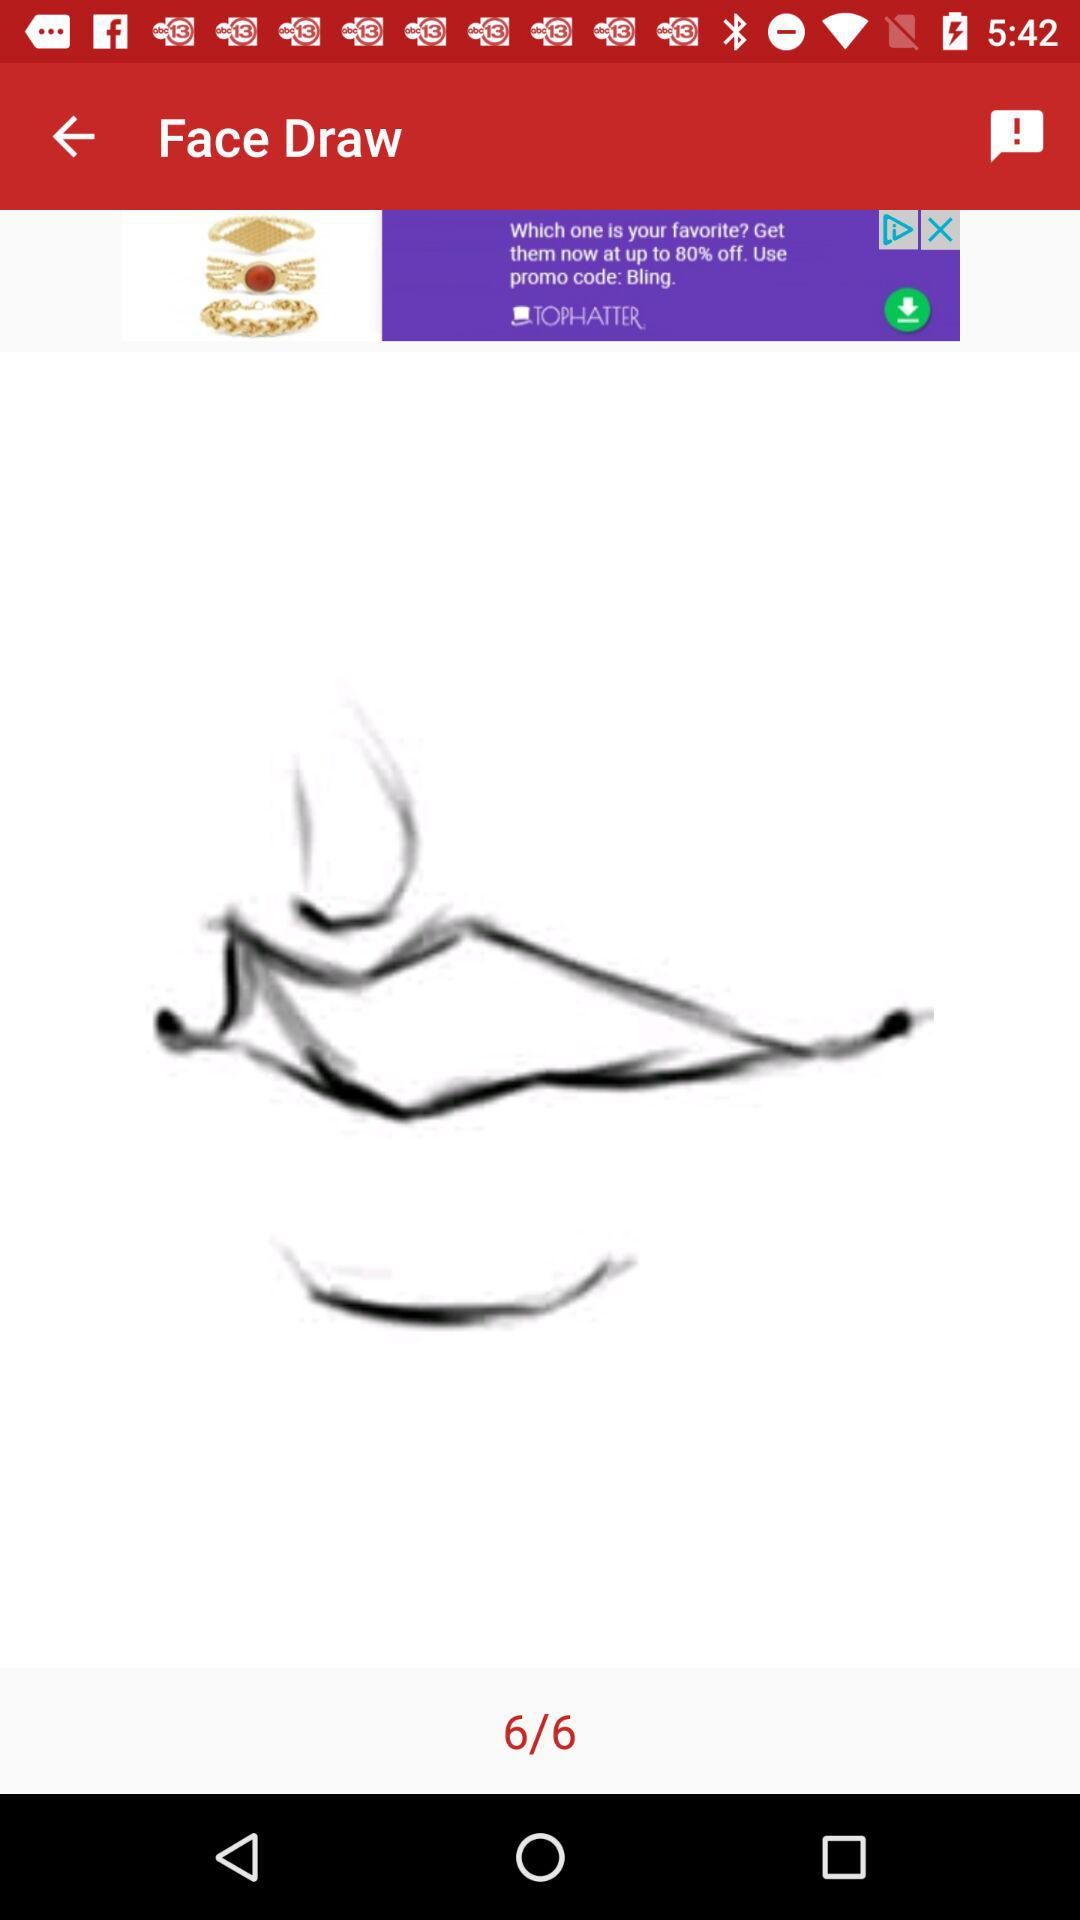What is the current page number? The current page number is 6. 